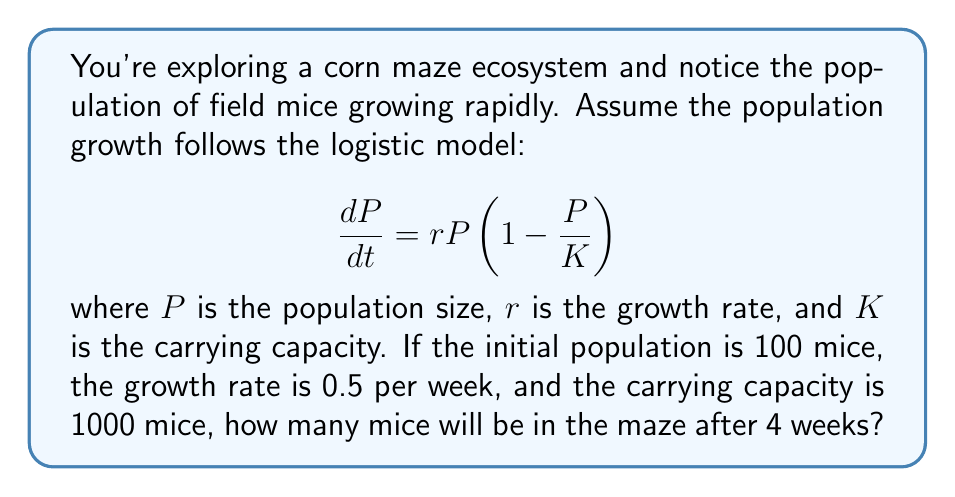Teach me how to tackle this problem. To solve this problem, we need to use the solution to the logistic differential equation:

$$P(t) = \frac{KP_0e^{rt}}{K + P_0(e^{rt} - 1)}$$

Where:
$P(t)$ is the population at time $t$
$K$ is the carrying capacity
$P_0$ is the initial population
$r$ is the growth rate
$t$ is the time

Given:
$P_0 = 100$ mice
$r = 0.5$ per week
$K = 1000$ mice
$t = 4$ weeks

Let's substitute these values into the equation:

$$P(4) = \frac{1000 \cdot 100 \cdot e^{0.5 \cdot 4}}{1000 + 100(e^{0.5 \cdot 4} - 1)}$$

Now, let's calculate step by step:

1. Calculate $e^{0.5 \cdot 4}$:
   $e^2 \approx 7.3891$

2. Substitute this value:
   $$P(4) = \frac{100000 \cdot 7.3891}{1000 + 100(7.3891 - 1)}$$

3. Simplify:
   $$P(4) = \frac{738910}{1000 + 638.91} = \frac{738910}{1638.91}$$

4. Calculate the final result:
   $P(4) \approx 450.85$

5. Since we're dealing with a population of mice, we round to the nearest whole number:
   $P(4) \approx 451$ mice
Answer: After 4 weeks, there will be approximately 451 mice in the corn maze ecosystem. 